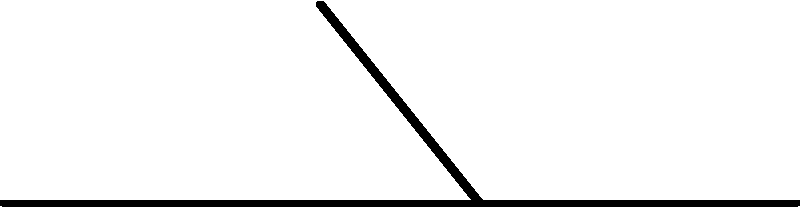During a sliding tackle, a player's foot experiences vertical and horizontal ground reaction forces. If the vertical force ($F_v$) is 800N and the horizontal force ($F_h$) is 600N, what is the magnitude of the total ground reaction force ($F_t$) acting on the player's foot? To find the magnitude of the total ground reaction force, we need to follow these steps:

1. Identify the given forces:
   Vertical force ($F_v$) = 800N
   Horizontal force ($F_h$) = 600N

2. Recognize that the vertical and horizontal forces form a right angle, creating a right triangle.

3. Use the Pythagorean theorem to calculate the magnitude of the total force:
   $F_t^2 = F_v^2 + F_h^2$

4. Substitute the known values:
   $F_t^2 = 800^2 + 600^2$

5. Calculate the squares:
   $F_t^2 = 640,000 + 360,000 = 1,000,000$

6. Take the square root of both sides:
   $F_t = \sqrt{1,000,000} = 1000$

Therefore, the magnitude of the total ground reaction force is 1000N.
Answer: 1000N 